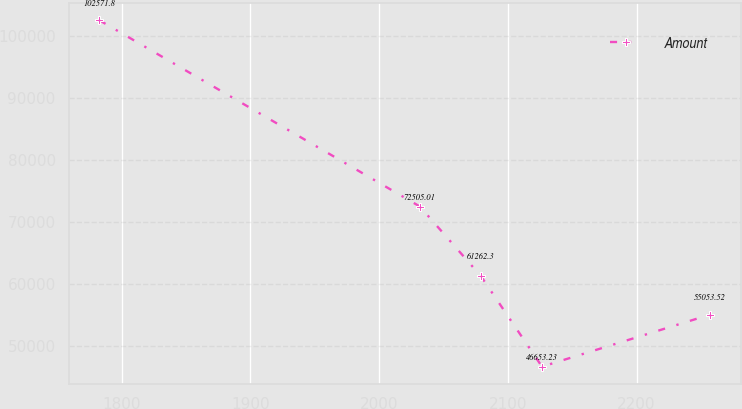Convert chart. <chart><loc_0><loc_0><loc_500><loc_500><line_chart><ecel><fcel>Amount<nl><fcel>1782.61<fcel>102572<nl><fcel>2031.64<fcel>72505<nl><fcel>2079.09<fcel>61262.3<nl><fcel>2126.54<fcel>46653.2<nl><fcel>2257.15<fcel>55053.5<nl></chart> 